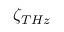Convert formula to latex. <formula><loc_0><loc_0><loc_500><loc_500>\zeta _ { T H z }</formula> 